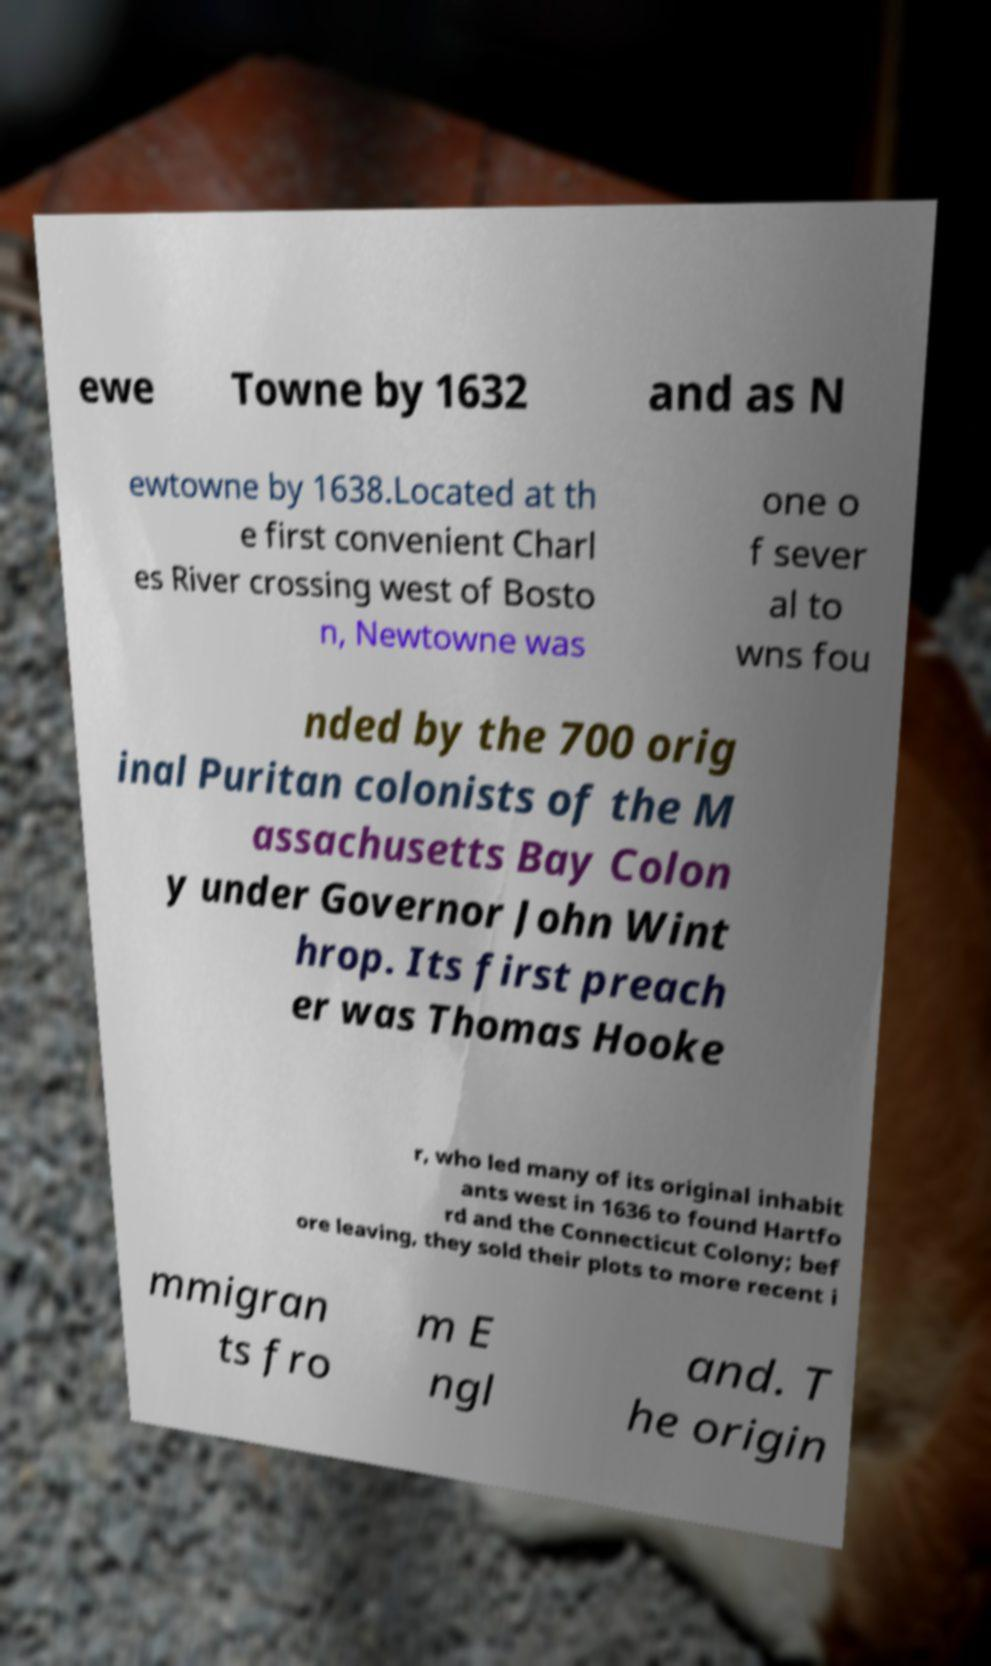I need the written content from this picture converted into text. Can you do that? ewe Towne by 1632 and as N ewtowne by 1638.Located at th e first convenient Charl es River crossing west of Bosto n, Newtowne was one o f sever al to wns fou nded by the 700 orig inal Puritan colonists of the M assachusetts Bay Colon y under Governor John Wint hrop. Its first preach er was Thomas Hooke r, who led many of its original inhabit ants west in 1636 to found Hartfo rd and the Connecticut Colony; bef ore leaving, they sold their plots to more recent i mmigran ts fro m E ngl and. T he origin 